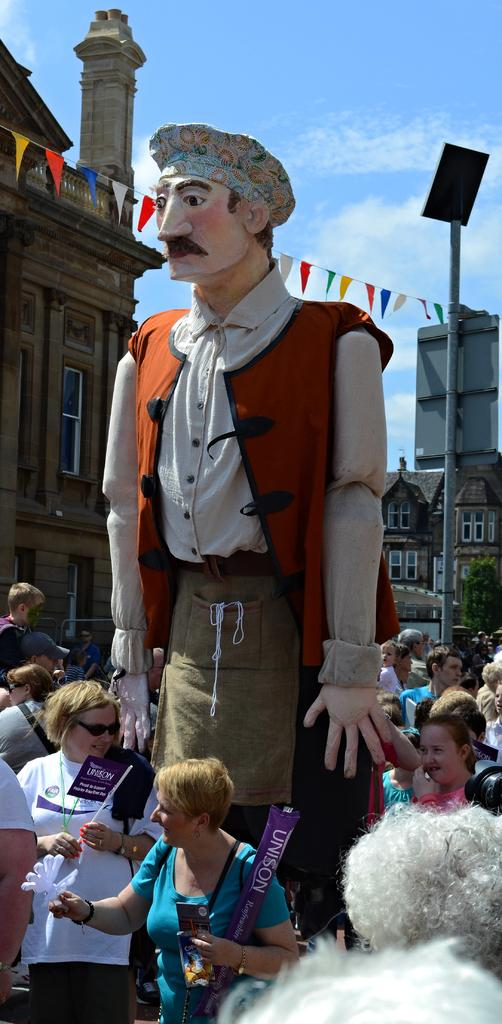How many people are in the group visible in the image? There is a group of people in the image, but the exact number cannot be determined from the provided facts. What is the main object in the foreground of the image? There is a statue in the image. What can be seen in the background of the image? Buildings, paper flags, a pole, and clouds are visible in the background of the image. What type of bead is being used to decorate the cake in the image? There is no cake or bead present in the image. What type of hydrant is visible in the background of the image? There is no hydrant present in the image. 